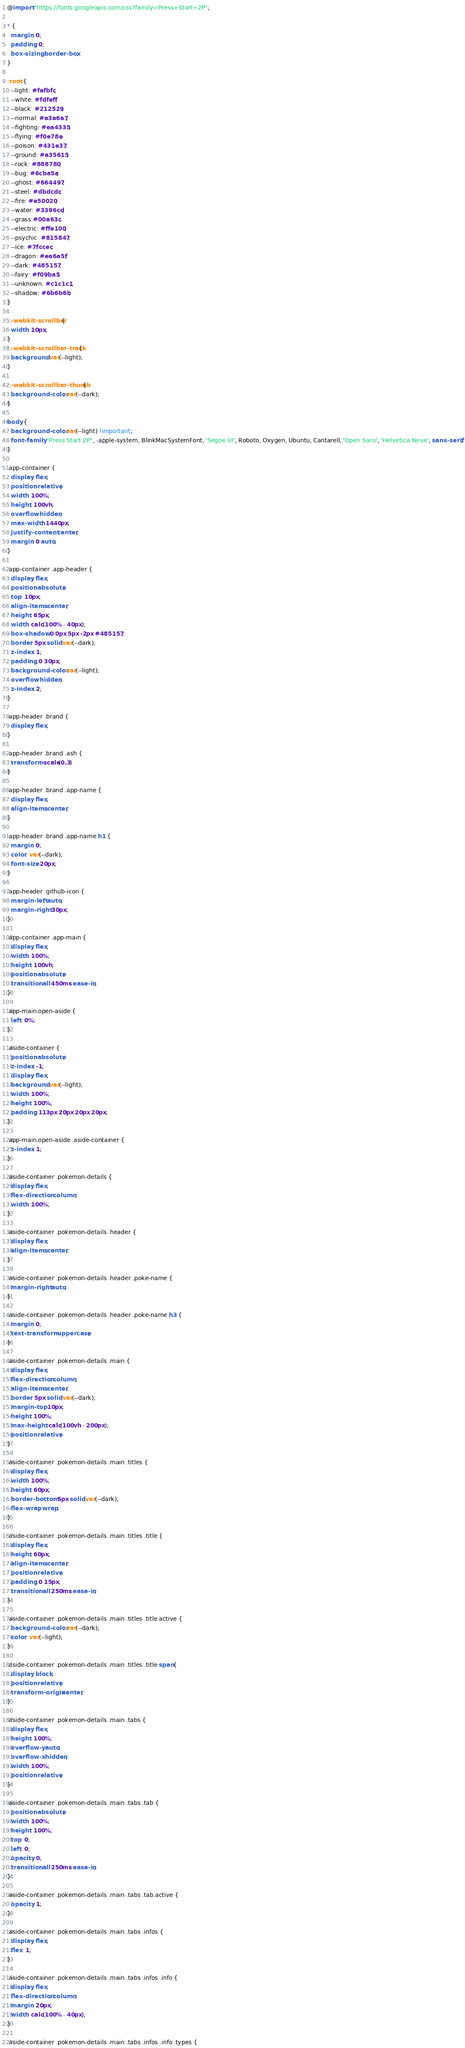Convert code to text. <code><loc_0><loc_0><loc_500><loc_500><_CSS_>@import "https://fonts.googleapis.com/css?family=Press+Start+2P";

* {
  margin: 0;
  padding: 0;
  box-sizing: border-box;
}

:root {
  --light: #fafbfc;
  --white: #fdfeff;
  --black: #212529;
  --normal: #a3a6a7;
  --fighting: #ea4335;
  --flying: #f0e78e;
  --poison: #431e37;
  --ground: #a35615;
  --rock: #888780;
  --bug: #6cba5a;
  --ghost: #664497;
  --steel: #dbdcdc;
  --fire: #e50020;
  --water: #3396cd;
  --grass:#00a63c;
  --electric: #ffe100;
  --psychic: #815847;
  --ice: #7fccec;
  --dragon: #ea6a5f;
  --dark: #485157;
  --fairy: #f09ba5;
  --unknown: #c1c1c1;
  --shadow: #6b6b6b;
}

::-webkit-scrollbar {
  width: 10px;            
}
::-webkit-scrollbar-track {
  background: var(--light);      
}

::-webkit-scrollbar-thumb {
  background-color: var(--dark);    
}

body {
  background-color: var(--light) !important;
  font-family: "Press Start 2P", -apple-system, BlinkMacSystemFont, 'Segoe UI', Roboto, Oxygen, Ubuntu, Cantarell, 'Open Sans', 'Helvetica Neue', sans-serif;
}

.app-container {
  display: flex;
  position: relative;
  width: 100%;
  height: 100vh;
  overflow: hidden;
  max-width: 1440px;
  justify-content: center;
  margin: 0 auto;
}

.app-container .app-header {
  display: flex;
  position: absolute;
  top: 10px;
  align-items: center;
  height: 65px;
  width: calc(100% - 40px);
  box-shadow: 0 0px 5px -2px #485157;
  border: 5px solid var(--dark);
  z-index: 1;
  padding: 0 30px;
  background-color: var(--light);
  overflow: hidden;
  z-index: 2;
}

.app-header .brand {
  display: flex;
}

.app-header .brand .ash {
  transform: scale(0.3)
}

.app-header .brand .app-name {
  display: flex;
  align-items: center;
}

.app-header .brand .app-name h1 {
  margin: 0;
  color: var(--dark);
  font-size: 20px;
}

.app-header .github-icon {
  margin-left: auto;
  margin-right: 30px;
}

.app-container .app-main {
  display: flex;
  width: 100%;
  height: 100vh;
  position: absolute;
  transition: all 450ms ease-in;
}

.app-main.open-aside {
  left: 0%;
}

.aside-container {
  position: absolute;
  z-index: -1;
  display: flex;
  background: var(--light);
  width: 100%;
  height: 100%;
  padding: 113px 20px 20px 20px;
}

.app-main.open-aside .aside-container {
  z-index: 1; 
}

.aside-container .pokemon-details {
  display: flex;
  flex-direction: column;
  width: 100%;
}

.aside-container .pokemon-details .header {
  display: flex;
  align-items: center;
}

.aside-container .pokemon-details .header .poke-name {
  margin-right: auto;
}

.aside-container .pokemon-details .header .poke-name h3 {
  margin: 0;
  text-transform: uppercase;
}

.aside-container .pokemon-details .main {
  display: flex;
  flex-direction: column;
  align-items: center;
  border: 5px solid var(--dark);
  margin-top: 10px;
  height: 100%;
  max-height: calc(100vh - 200px);
  position: relative;
}

.aside-container .pokemon-details .main .titles {
  display: flex;
  width: 100%;
  height: 60px;
  border-bottom: 5px solid var(--dark);
  flex-wrap: wrap;
}

.aside-container .pokemon-details .main .titles .title {
  display: flex;
  height: 60px;
  align-items: center;
  position: relative;
  padding: 0 15px;
  transition: all 250ms ease-in;
}

.aside-container .pokemon-details .main .titles .title.active {
  background-color: var(--dark);
  color: var(--light);
}

.aside-container .pokemon-details .main .titles .title span{
  display: block;
  position: relative;
  transform-origin: center;
}

.aside-container .pokemon-details .main .tabs {
  display: flex;
  height: 100%;
  overflow-y: auto;
  overflow-x: hidden;
  width: 100%;
  position: relative;
}

.aside-container .pokemon-details .main .tabs .tab {
  position: absolute;
  width: 100%;
  height: 100%;
  top: 0;
  left: 0;
  opacity: 0;
  transition: all 250ms ease-in;
}

.aside-container .pokemon-details .main .tabs .tab.active {
  opacity: 1;
}

.aside-container .pokemon-details .main .tabs .infos {
  display: flex;
  flex: 1;
}

.aside-container .pokemon-details .main .tabs .infos .info {
  display: flex;
  flex-direction: column;
  margin: 20px;
  width: calc(100% - 40px);
}

.aside-container .pokemon-details .main .tabs .infos .info .types {</code> 